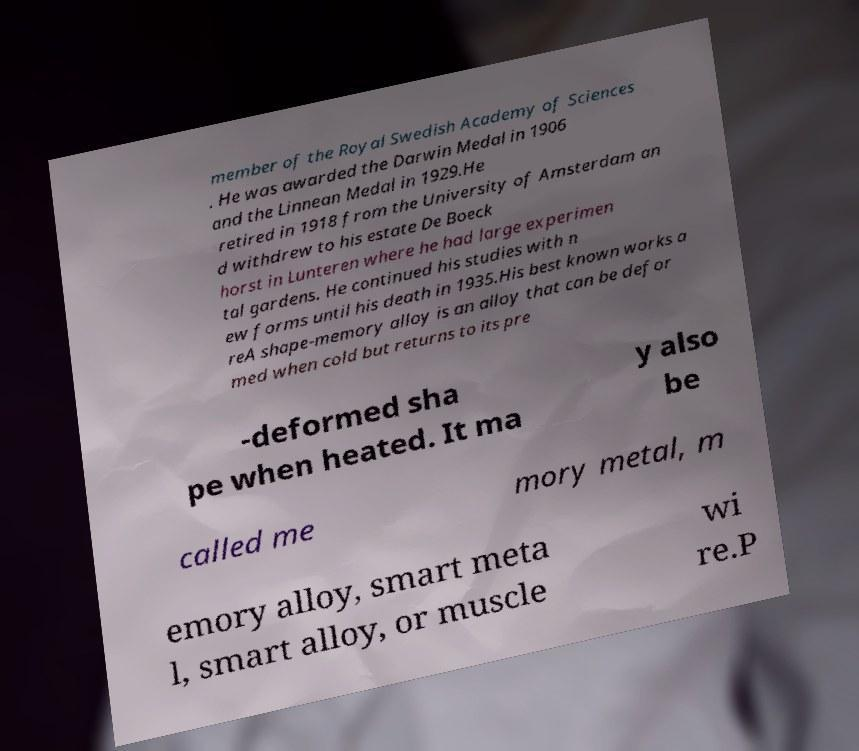Please identify and transcribe the text found in this image. member of the Royal Swedish Academy of Sciences . He was awarded the Darwin Medal in 1906 and the Linnean Medal in 1929.He retired in 1918 from the University of Amsterdam an d withdrew to his estate De Boeck horst in Lunteren where he had large experimen tal gardens. He continued his studies with n ew forms until his death in 1935.His best known works a reA shape-memory alloy is an alloy that can be defor med when cold but returns to its pre -deformed sha pe when heated. It ma y also be called me mory metal, m emory alloy, smart meta l, smart alloy, or muscle wi re.P 